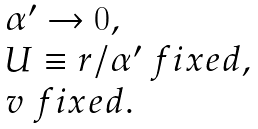Convert formula to latex. <formula><loc_0><loc_0><loc_500><loc_500>\begin{array} { l } \alpha ^ { \prime } \to 0 , \\ U \equiv r / \alpha ^ { \prime } \ f i x e d , \\ v \ f i x e d . \end{array}</formula> 